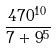<formula> <loc_0><loc_0><loc_500><loc_500>\frac { 4 7 0 ^ { 1 0 } } { 7 + 9 ^ { 5 } }</formula> 